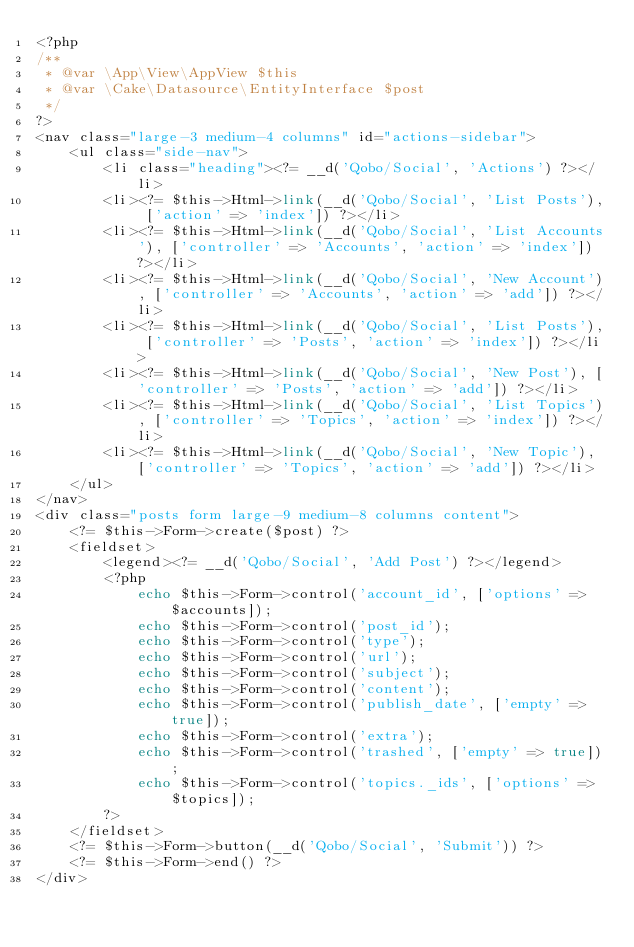Convert code to text. <code><loc_0><loc_0><loc_500><loc_500><_PHP_><?php
/**
 * @var \App\View\AppView $this
 * @var \Cake\Datasource\EntityInterface $post
 */
?>
<nav class="large-3 medium-4 columns" id="actions-sidebar">
    <ul class="side-nav">
        <li class="heading"><?= __d('Qobo/Social', 'Actions') ?></li>
        <li><?= $this->Html->link(__d('Qobo/Social', 'List Posts'), ['action' => 'index']) ?></li>
        <li><?= $this->Html->link(__d('Qobo/Social', 'List Accounts'), ['controller' => 'Accounts', 'action' => 'index']) ?></li>
        <li><?= $this->Html->link(__d('Qobo/Social', 'New Account'), ['controller' => 'Accounts', 'action' => 'add']) ?></li>
        <li><?= $this->Html->link(__d('Qobo/Social', 'List Posts'), ['controller' => 'Posts', 'action' => 'index']) ?></li>
        <li><?= $this->Html->link(__d('Qobo/Social', 'New Post'), ['controller' => 'Posts', 'action' => 'add']) ?></li>
        <li><?= $this->Html->link(__d('Qobo/Social', 'List Topics'), ['controller' => 'Topics', 'action' => 'index']) ?></li>
        <li><?= $this->Html->link(__d('Qobo/Social', 'New Topic'), ['controller' => 'Topics', 'action' => 'add']) ?></li>
    </ul>
</nav>
<div class="posts form large-9 medium-8 columns content">
    <?= $this->Form->create($post) ?>
    <fieldset>
        <legend><?= __d('Qobo/Social', 'Add Post') ?></legend>
        <?php
            echo $this->Form->control('account_id', ['options' => $accounts]);
            echo $this->Form->control('post_id');
            echo $this->Form->control('type');
            echo $this->Form->control('url');
            echo $this->Form->control('subject');
            echo $this->Form->control('content');
            echo $this->Form->control('publish_date', ['empty' => true]);
            echo $this->Form->control('extra');
            echo $this->Form->control('trashed', ['empty' => true]);
            echo $this->Form->control('topics._ids', ['options' => $topics]);
        ?>
    </fieldset>
    <?= $this->Form->button(__d('Qobo/Social', 'Submit')) ?>
    <?= $this->Form->end() ?>
</div>
</code> 